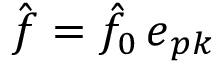<formula> <loc_0><loc_0><loc_500><loc_500>\hat { f } = \hat { f } _ { 0 } \, e _ { p k }</formula> 